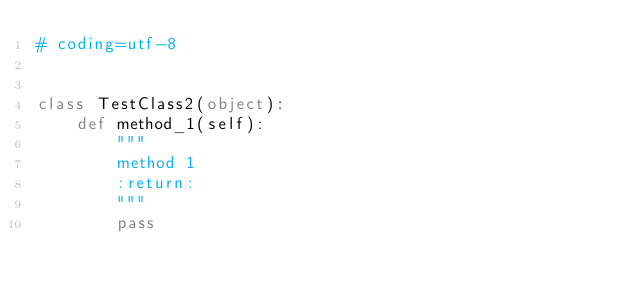<code> <loc_0><loc_0><loc_500><loc_500><_Python_># coding=utf-8


class TestClass2(object):
    def method_1(self):
        """
        method 1
        :return:
        """
        pass
</code> 